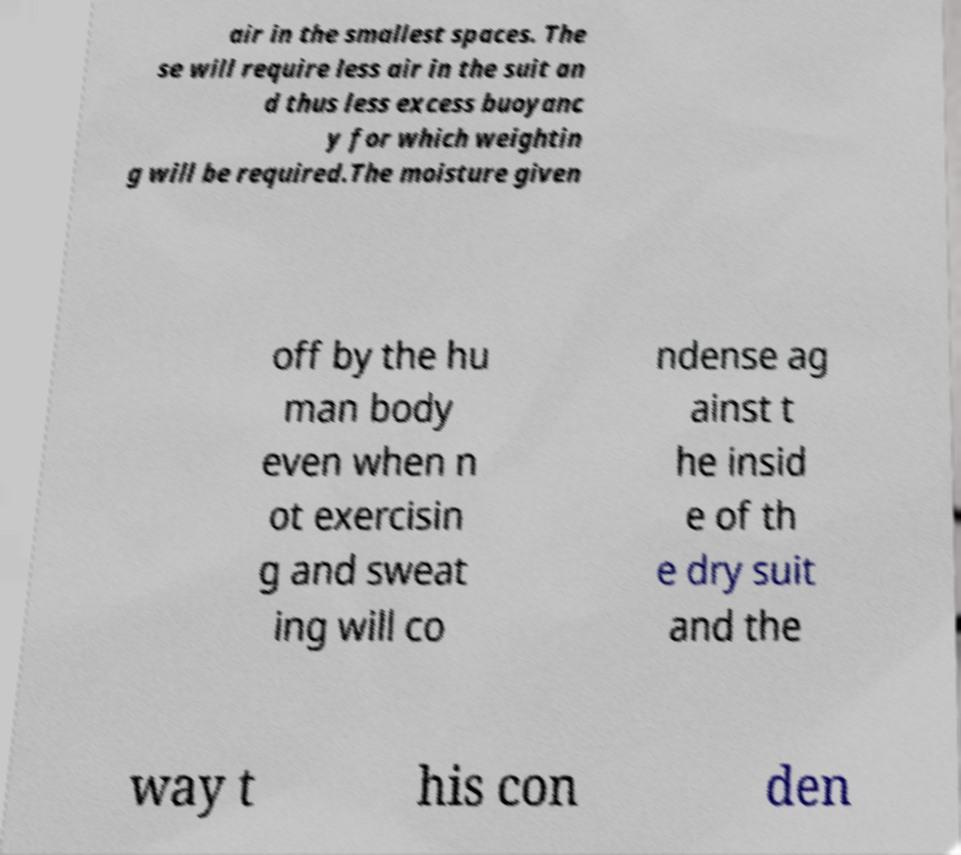Please identify and transcribe the text found in this image. air in the smallest spaces. The se will require less air in the suit an d thus less excess buoyanc y for which weightin g will be required.The moisture given off by the hu man body even when n ot exercisin g and sweat ing will co ndense ag ainst t he insid e of th e dry suit and the way t his con den 